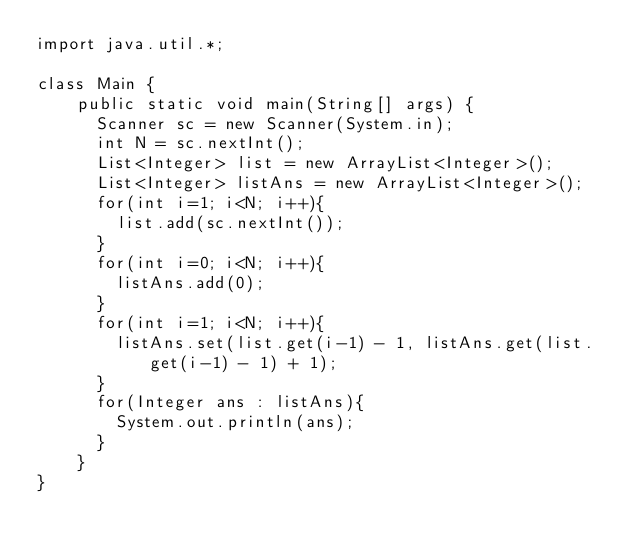Convert code to text. <code><loc_0><loc_0><loc_500><loc_500><_C_>import java.util.*;
 
class Main {
    public static void main(String[] args) {
      Scanner sc = new Scanner(System.in);
      int N = sc.nextInt();
      List<Integer> list = new ArrayList<Integer>();
      List<Integer> listAns = new ArrayList<Integer>();
      for(int i=1; i<N; i++){
        list.add(sc.nextInt());
      }
      for(int i=0; i<N; i++){
        listAns.add(0);
      }
      for(int i=1; i<N; i++){
        listAns.set(list.get(i-1) - 1, listAns.get(list.get(i-1) - 1) + 1);
      }
      for(Integer ans : listAns){
        System.out.println(ans); 
      }
    }
}</code> 